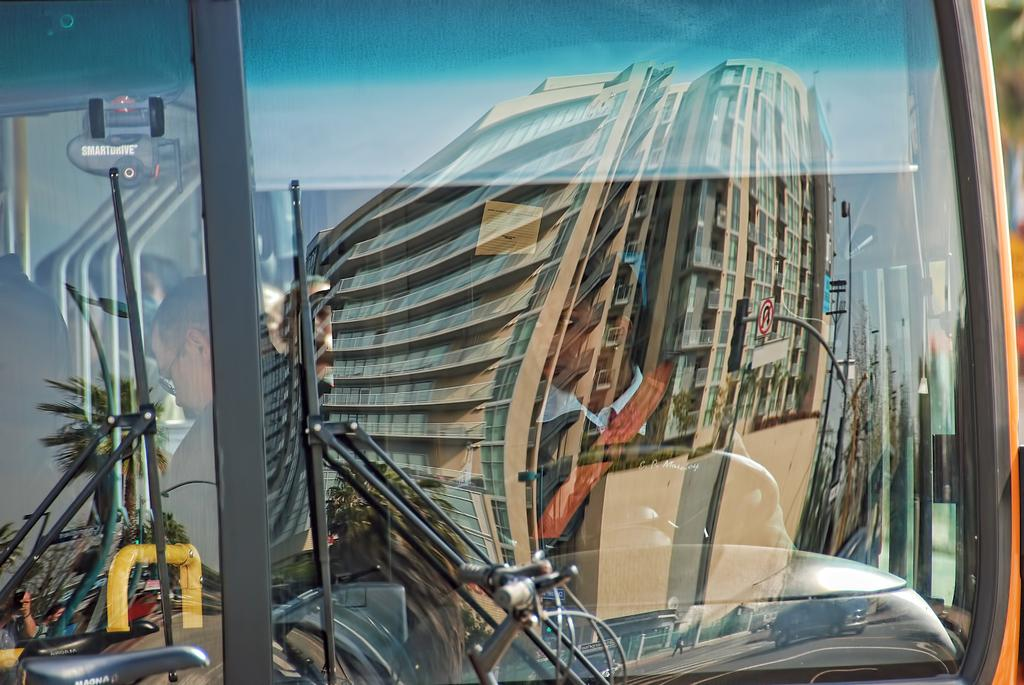What type of vehicle is depicted in the image? There is a glass of a vehicle in the image. Can you describe the person in the image? There is a woman in the image. Is there any other image within the main image? Yes, there is an image within the image. What type of structure can be seen in the background of the image? There is a building visible in the image. How many pizzas are being served by the woman in the image? There is no mention of pizzas in the image, nor is there any indication that the woman is serving anything. What type of boot is the woman wearing in the image? There is no information about the woman's footwear in the image. 